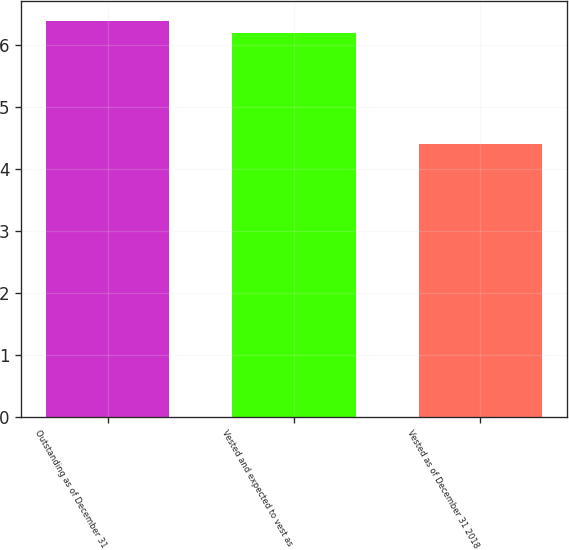Convert chart. <chart><loc_0><loc_0><loc_500><loc_500><bar_chart><fcel>Outstanding as of December 31<fcel>Vested and expected to vest as<fcel>Vested as of December 31 2018<nl><fcel>6.39<fcel>6.2<fcel>4.4<nl></chart> 